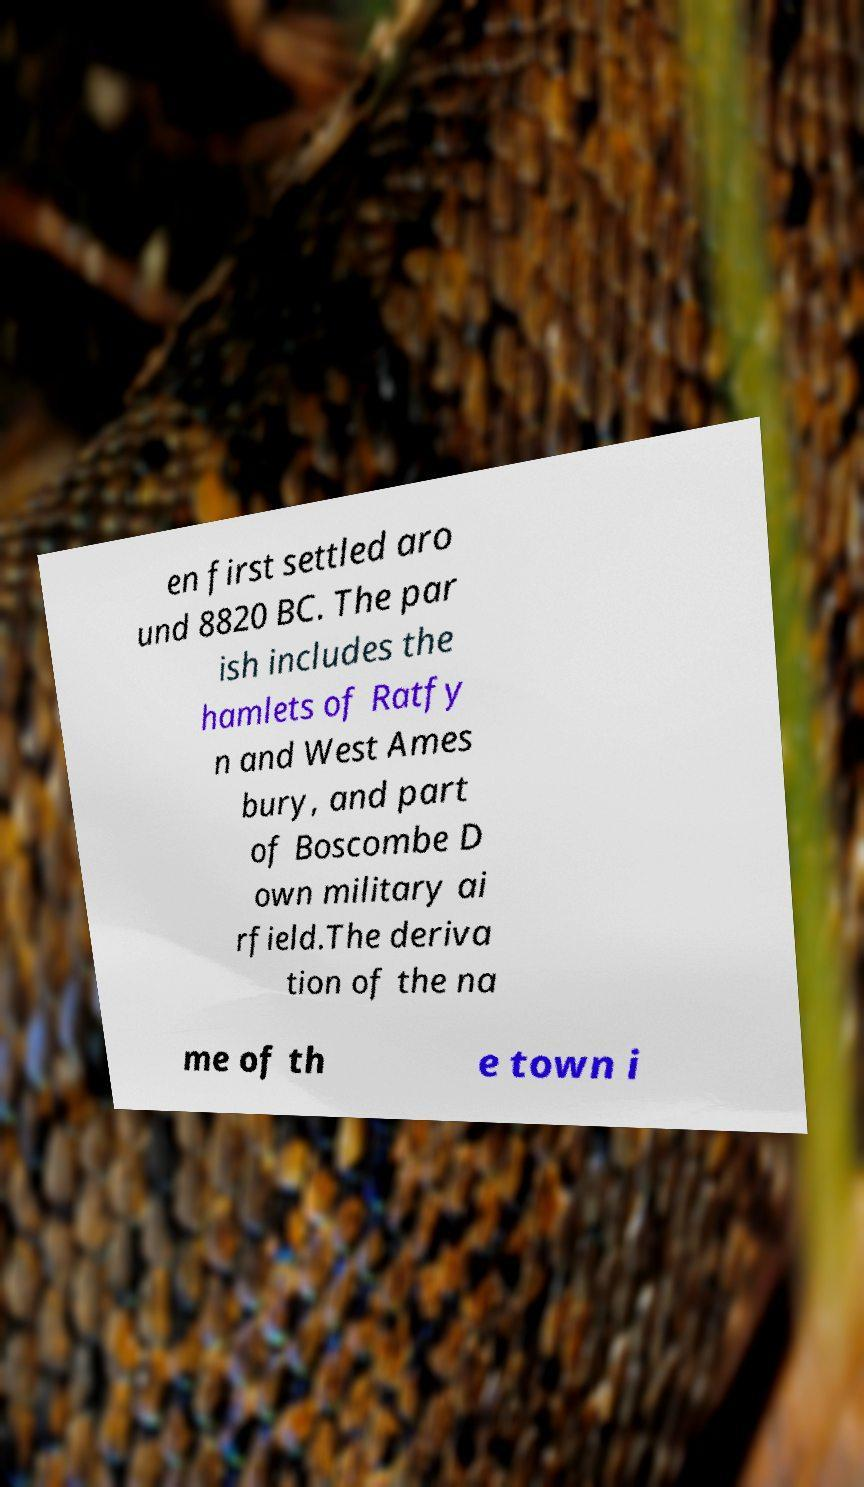Could you assist in decoding the text presented in this image and type it out clearly? en first settled aro und 8820 BC. The par ish includes the hamlets of Ratfy n and West Ames bury, and part of Boscombe D own military ai rfield.The deriva tion of the na me of th e town i 